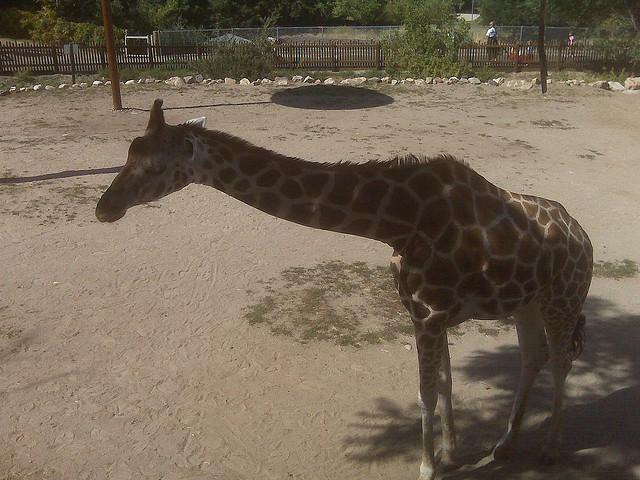How many bottles are on the table?
Give a very brief answer. 0. 